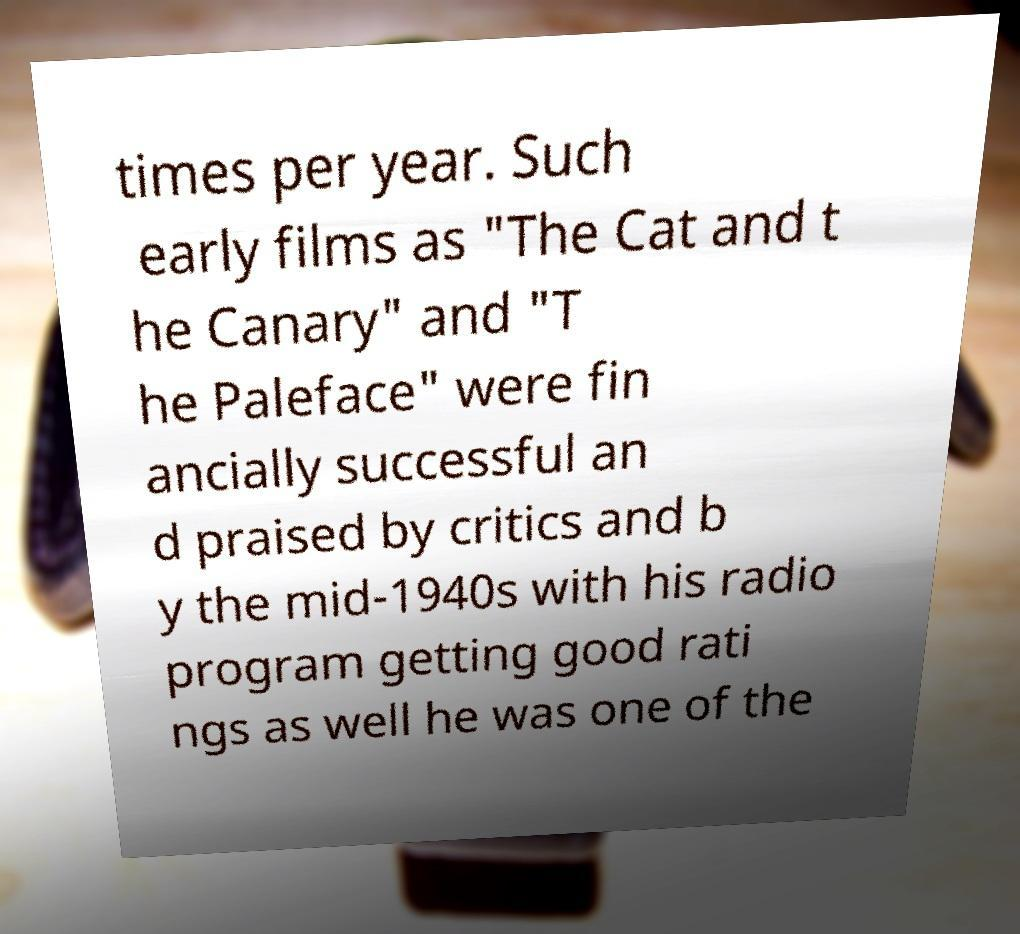Could you extract and type out the text from this image? times per year. Such early films as "The Cat and t he Canary" and "T he Paleface" were fin ancially successful an d praised by critics and b y the mid-1940s with his radio program getting good rati ngs as well he was one of the 